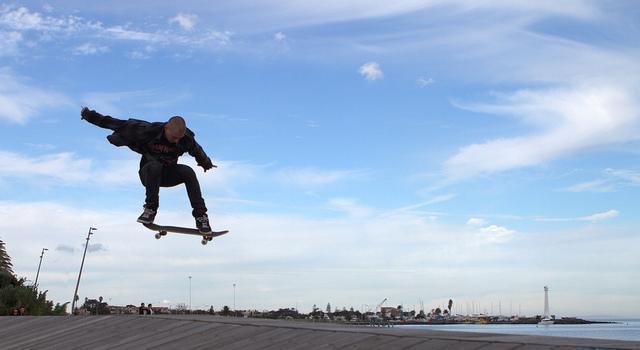How many people are in the picture?
Give a very brief answer. 1. How many people are in this picture?
Give a very brief answer. 1. 